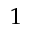<formula> <loc_0><loc_0><loc_500><loc_500>1</formula> 